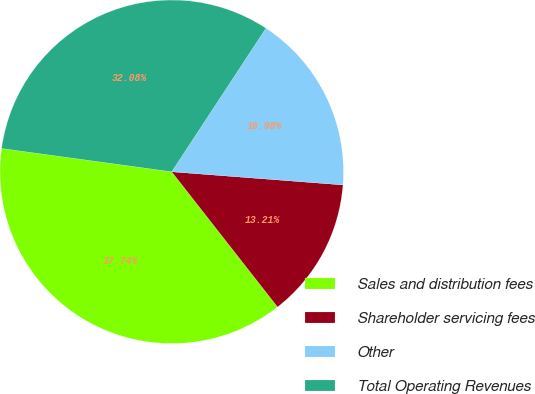Convert chart. <chart><loc_0><loc_0><loc_500><loc_500><pie_chart><fcel>Sales and distribution fees<fcel>Shareholder servicing fees<fcel>Other<fcel>Total Operating Revenues<nl><fcel>37.74%<fcel>13.21%<fcel>16.98%<fcel>32.08%<nl></chart> 